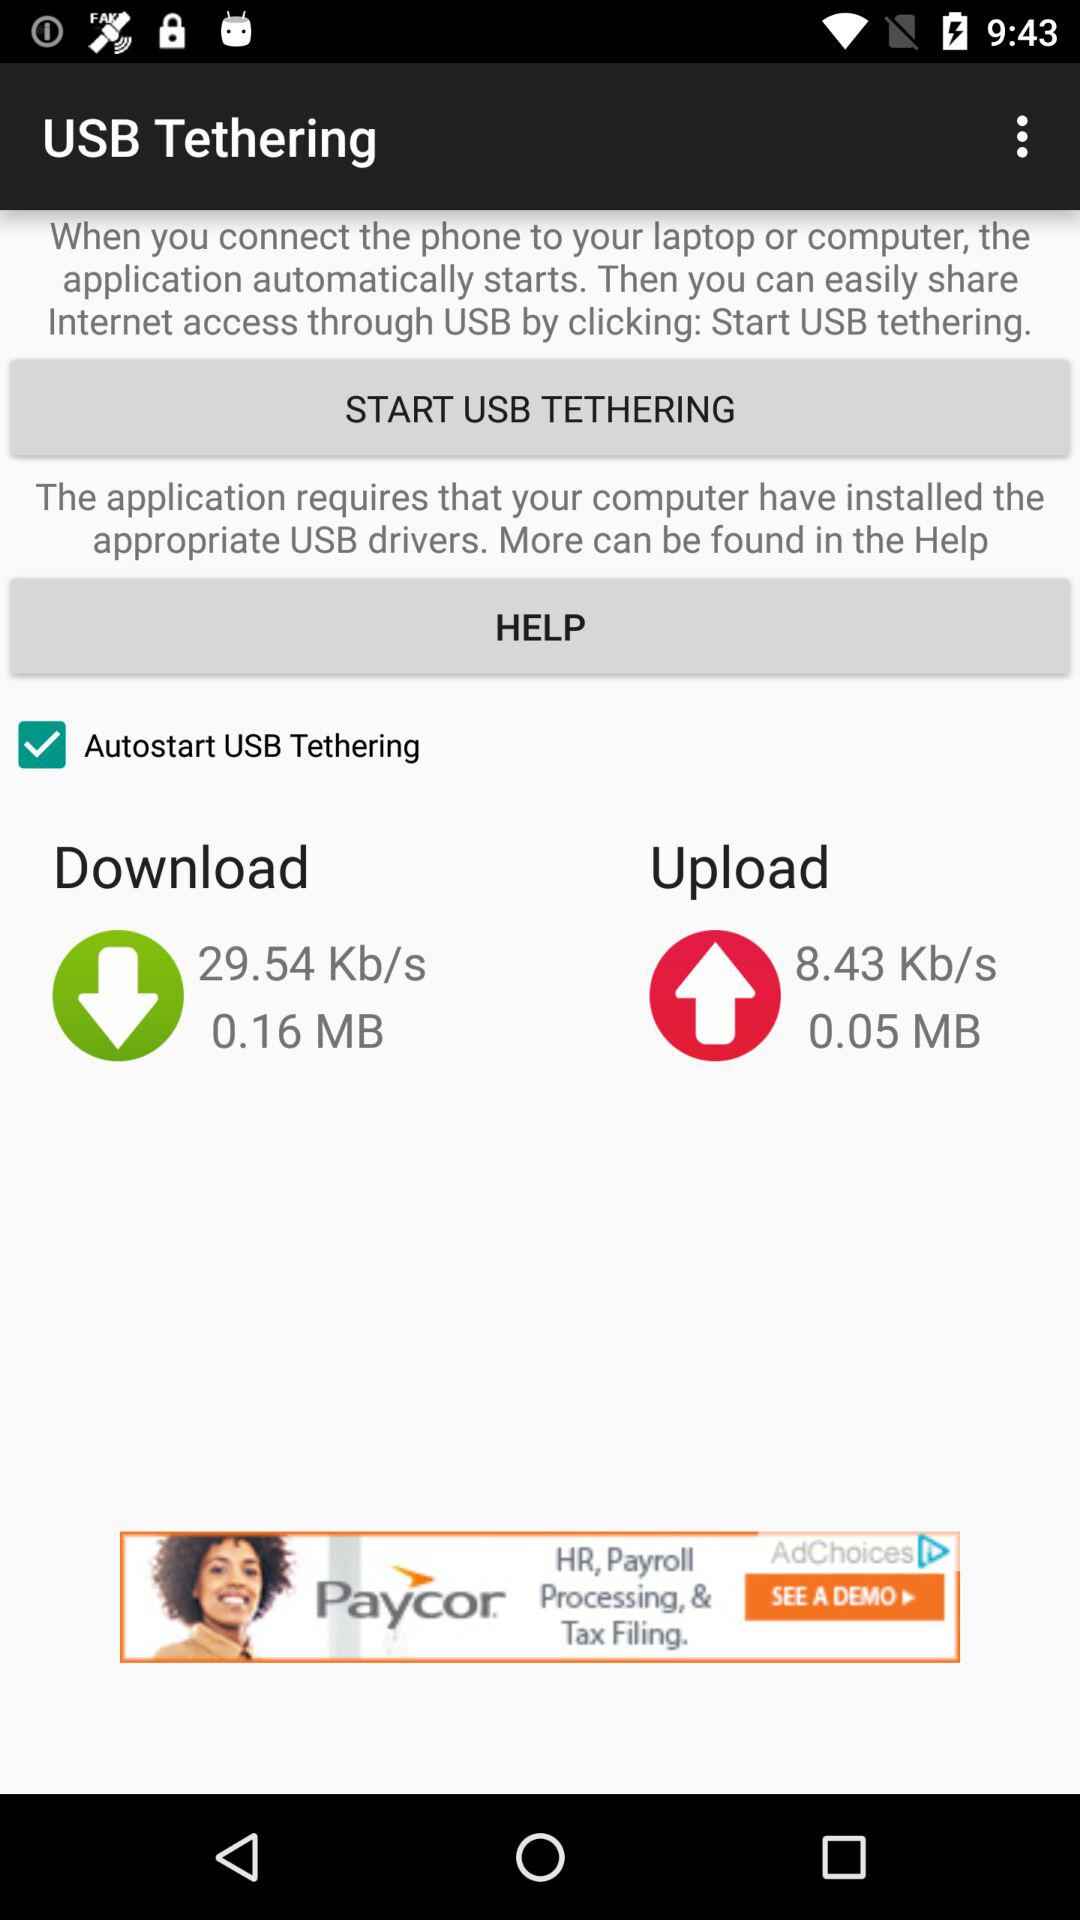How much data has been downloaded since the last reset?
Answer the question using a single word or phrase. 0.16 MB 